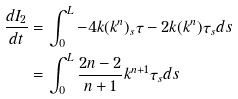Convert formula to latex. <formula><loc_0><loc_0><loc_500><loc_500>\frac { d I _ { 2 } } { d t } & = \int _ { 0 } ^ { L } - 4 k ( k ^ { n } ) _ { s } \tau - 2 k ( k ^ { n } ) \tau _ { s } d s \\ & = \int _ { 0 } ^ { L } \frac { 2 n - 2 } { n + 1 } { k ^ { n + 1 } } \tau _ { s } d s</formula> 